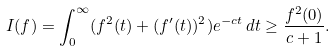<formula> <loc_0><loc_0><loc_500><loc_500>I ( f ) = \int _ { 0 } ^ { \infty } ( f ^ { 2 } ( t ) + ( f ^ { \prime } ( t ) ) ^ { 2 } ) e ^ { - c t } \, d t \geq \frac { f ^ { 2 } ( 0 ) } { c + 1 } .</formula> 